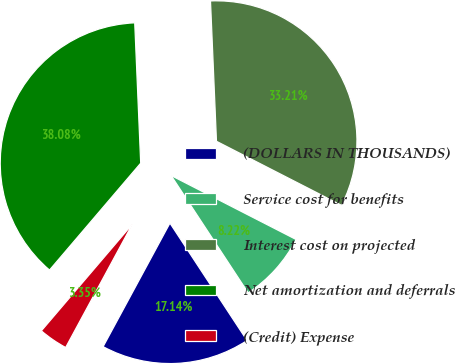Convert chart. <chart><loc_0><loc_0><loc_500><loc_500><pie_chart><fcel>(DOLLARS IN THOUSANDS)<fcel>Service cost for benefits<fcel>Interest cost on projected<fcel>Net amortization and deferrals<fcel>(Credit) Expense<nl><fcel>17.14%<fcel>8.22%<fcel>33.21%<fcel>38.08%<fcel>3.35%<nl></chart> 